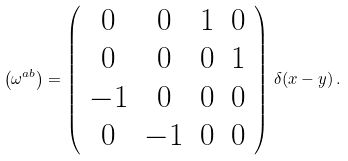Convert formula to latex. <formula><loc_0><loc_0><loc_500><loc_500>\left ( \omega ^ { a b } \right ) = \left ( \begin{array} { c c c c } { 0 } & { 0 } & { 1 } & { 0 } \\ { 0 } & { 0 } & { 0 } & { 1 } \\ { - 1 } & { 0 } & { 0 } & { 0 } \\ { 0 } & { - 1 } & { 0 } & { 0 } \end{array} \right ) \, \delta ( x - y ) \, .</formula> 